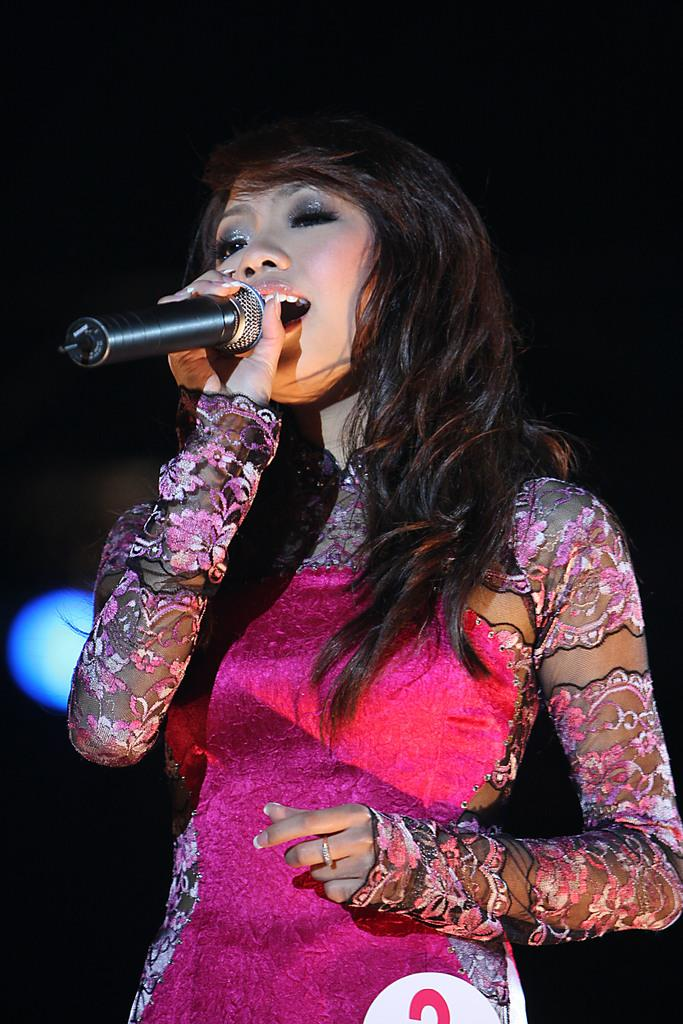Who is the main subject in the image? There is a woman in the image. What is the woman wearing? The woman is wearing a pink dress. What is the woman holding in the image? The woman is holding a microphone. What is the woman doing in the image? The woman is singing a song. What is the color of the background in the image? The background of the image is dark. What type of attack is the pig performing in the image? There is no pig present in the image, and therefore no attack can be observed. What mathematical operation is the woman performing with the microphone in the image? The woman is not performing any mathematical operation with the microphone; she is singing a song. 